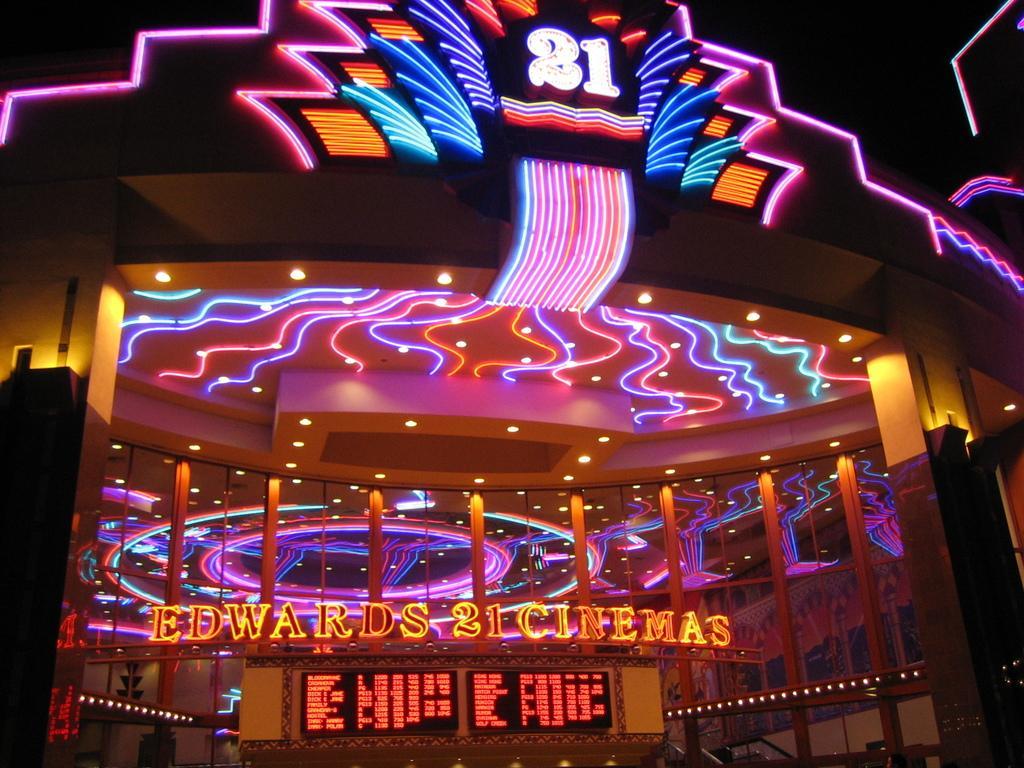Could you give a brief overview of what you see in this image? In this image I can see a screen in black color. Background I can see few colorful lights. 